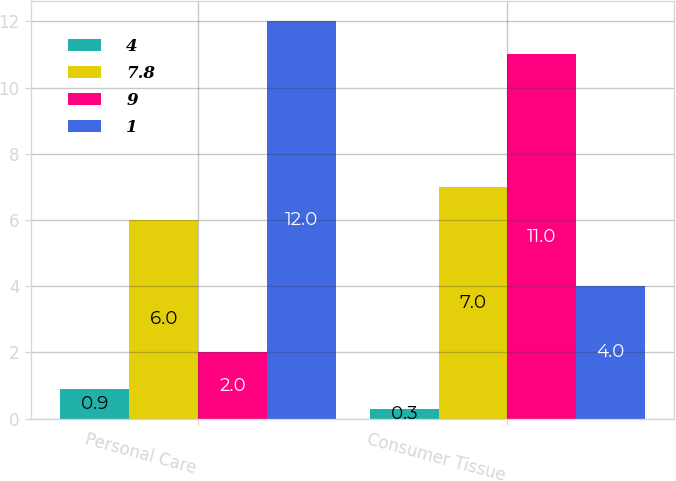Convert chart to OTSL. <chart><loc_0><loc_0><loc_500><loc_500><stacked_bar_chart><ecel><fcel>Personal Care<fcel>Consumer Tissue<nl><fcel>4<fcel>0.9<fcel>0.3<nl><fcel>7.8<fcel>6<fcel>7<nl><fcel>9<fcel>2<fcel>11<nl><fcel>1<fcel>12<fcel>4<nl></chart> 